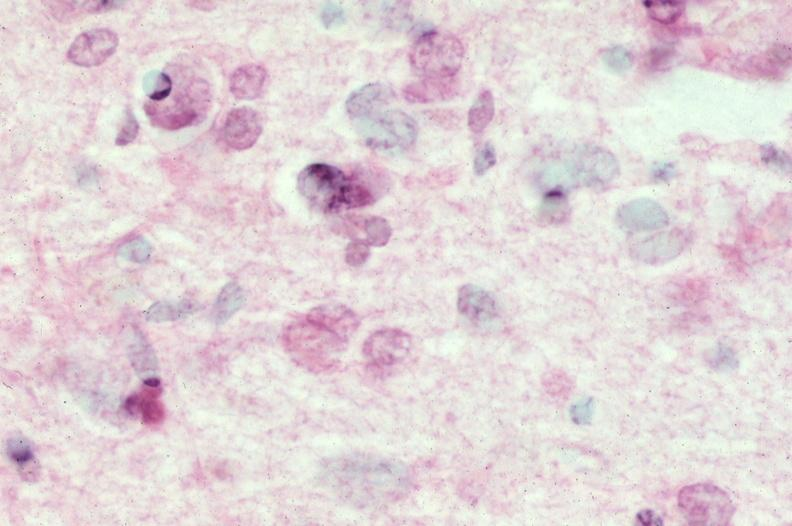s opened muscle present?
Answer the question using a single word or phrase. No 